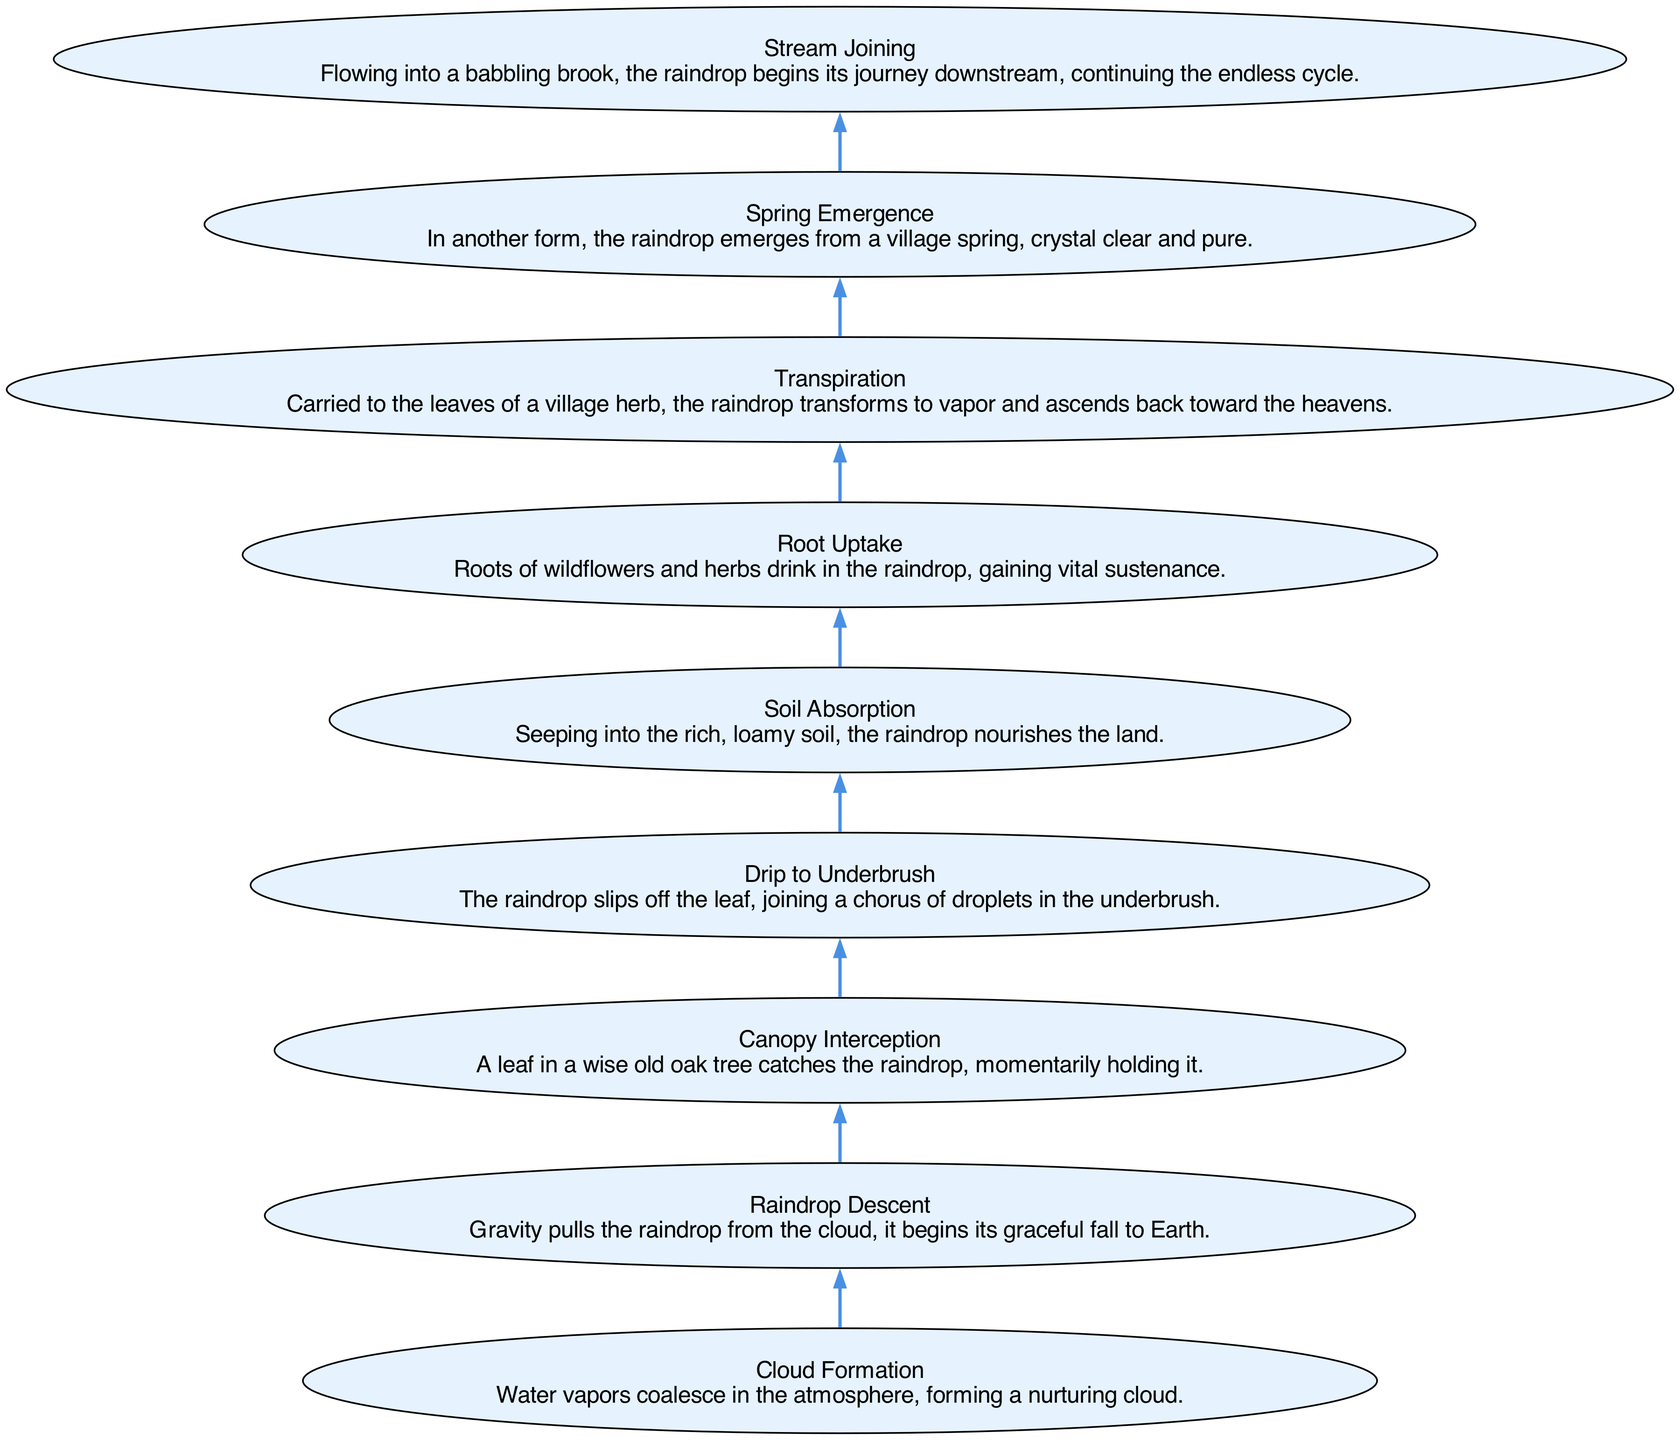What is the first step in the journey of the raindrop? The diagram starts at the bottom with "Cloud Formation," which marks the beginning of the raindrop's journey.
Answer: Cloud Formation How many steps are there in the raindrop's journey? By counting the nodes in the diagram, there are a total of nine distinct steps from the cloud to the stream.
Answer: Nine Which step directly follows "Soil Absorption"? After "Soil Absorption," the next step in the journey is "Root Uptake," where the raindrop is taken up by the plants.
Answer: Root Uptake What happens after "Transpiration"? Following "Transpiration," the raindrop's next phase is "Spring Emergence," indicating its transformation back to liquid form at a spring.
Answer: Spring Emergence What is the relationship between "Raindrop Descent" and "Canopy Interception"? "Raindrop Descent" precedes "Canopy Interception" in the flow, as the raindrop falls from the cloud and is then caught by a leaf.
Answer: Precedes In which node does the raindrop transform from liquid to vapor? The transformation occurs at the "Transpiration" node, where the raindrop becomes vapor and rises again.
Answer: Transpiration Which step represents the raindrop's entry into the surface water system? The raindrop enters the surface water system at the "Stream Joining" step, where it flows into a brook.
Answer: Stream Joining How does the raindrop nourish the land? The "Soil Absorption" step shows how the raindrop nourishes the soil as it seeps into the ground, benefiting plant life.
Answer: Soil Absorption What is the ultimate destination of the raindrop after it flows into the stream? The final destination in the cycle is the stream, where the raindrop continues its journey downstream, contributing to the ecosystem.
Answer: Stream 